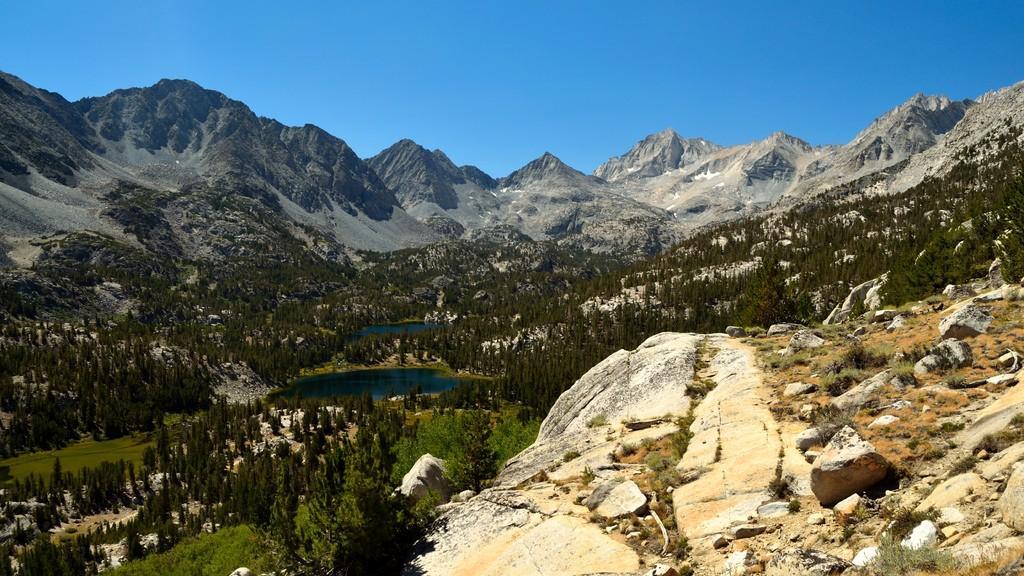Could you give a brief overview of what you see in this image? In this picture I can see rocks, trees, water, mountains, and in the background there is sky. 